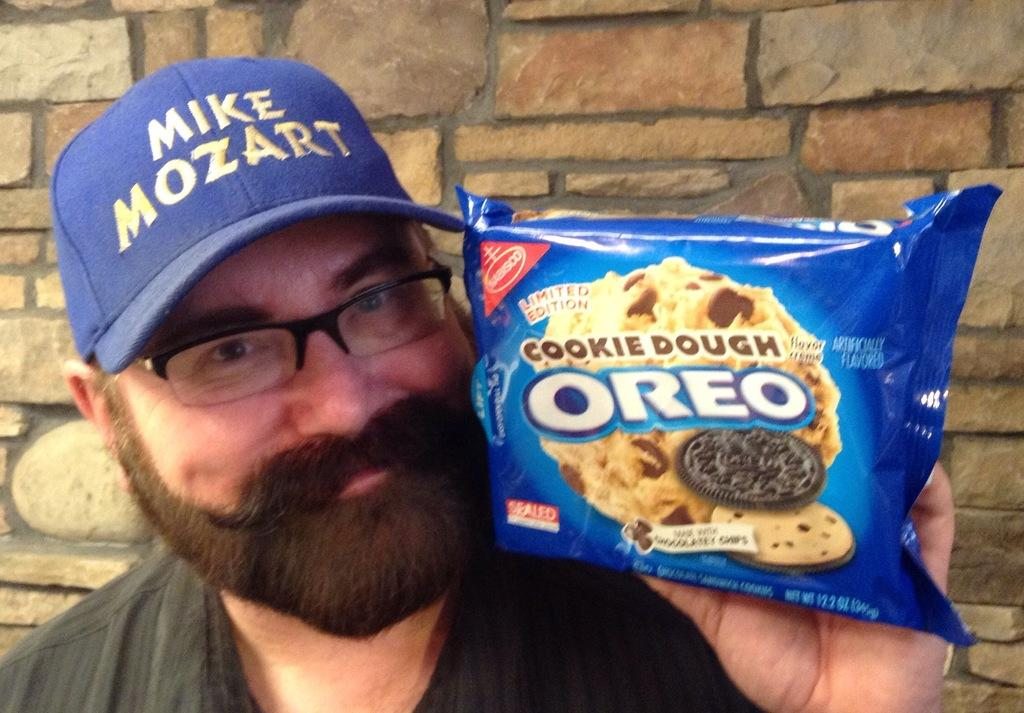Who is the main subject in the image? There is a person in the center of the image. What is the person holding in his hand? The person is holding a biscuit packet in his hand. What type of headwear is the person wearing? The person is wearing a cap. What can be seen in the background of the image? There is a wall in the background of the image. What color is the chalk used by the person to draw on the canvas in the image? There is no chalk or canvas present in the image; the person is holding a biscuit packet and wearing a cap. 